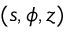<formula> <loc_0><loc_0><loc_500><loc_500>( s , \phi , z )</formula> 